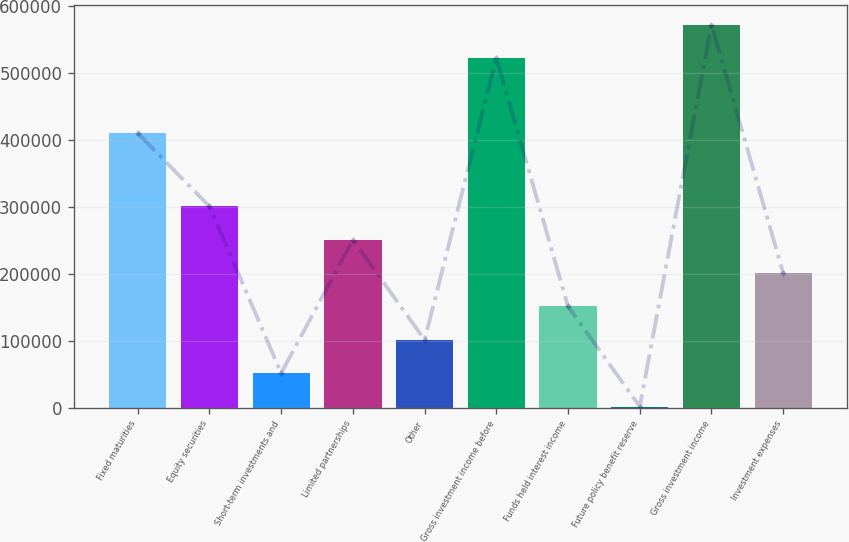Convert chart to OTSL. <chart><loc_0><loc_0><loc_500><loc_500><bar_chart><fcel>Fixed maturities<fcel>Equity securities<fcel>Short-term investments and<fcel>Limited partnerships<fcel>Other<fcel>Gross investment income before<fcel>Funds held interest income<fcel>Future policy benefit reserve<fcel>Gross investment income<fcel>Investment expenses<nl><fcel>410337<fcel>300972<fcel>51522.9<fcel>251082<fcel>101413<fcel>522975<fcel>151303<fcel>1633<fcel>572865<fcel>201193<nl></chart> 